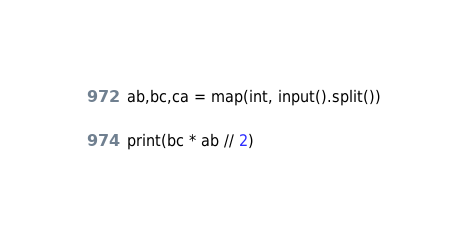<code> <loc_0><loc_0><loc_500><loc_500><_Python_>ab,bc,ca = map(int, input().split())

print(bc * ab // 2)</code> 